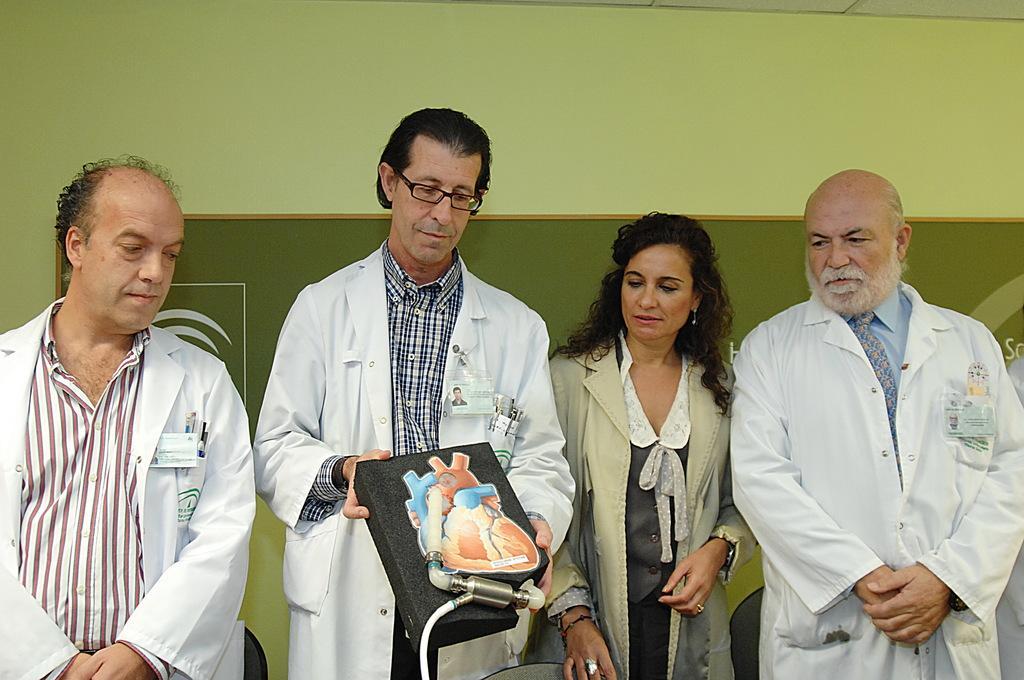In one or two sentences, can you explain what this image depicts? In this image we can see three men and a woman standing. We can also see a man holding an artificial picture of the heart, remaining three are looking at that. On the backside we can see a wall. 